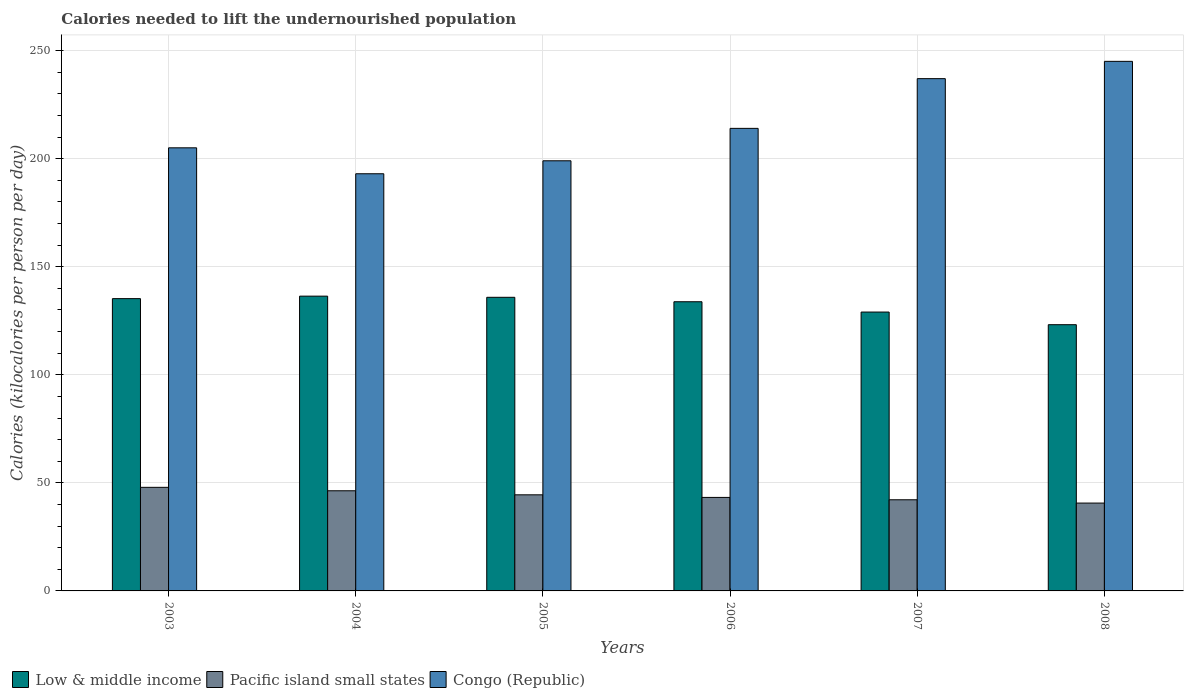How many different coloured bars are there?
Keep it short and to the point. 3. How many groups of bars are there?
Offer a terse response. 6. How many bars are there on the 1st tick from the left?
Offer a terse response. 3. What is the label of the 6th group of bars from the left?
Ensure brevity in your answer.  2008. In how many cases, is the number of bars for a given year not equal to the number of legend labels?
Keep it short and to the point. 0. What is the total calories needed to lift the undernourished population in Pacific island small states in 2004?
Keep it short and to the point. 46.33. Across all years, what is the maximum total calories needed to lift the undernourished population in Pacific island small states?
Your response must be concise. 47.92. Across all years, what is the minimum total calories needed to lift the undernourished population in Pacific island small states?
Your response must be concise. 40.64. In which year was the total calories needed to lift the undernourished population in Congo (Republic) maximum?
Provide a short and direct response. 2008. What is the total total calories needed to lift the undernourished population in Congo (Republic) in the graph?
Ensure brevity in your answer.  1293. What is the difference between the total calories needed to lift the undernourished population in Low & middle income in 2005 and that in 2007?
Your answer should be very brief. 6.83. What is the difference between the total calories needed to lift the undernourished population in Congo (Republic) in 2007 and the total calories needed to lift the undernourished population in Pacific island small states in 2008?
Offer a terse response. 196.36. What is the average total calories needed to lift the undernourished population in Congo (Republic) per year?
Your answer should be very brief. 215.5. In the year 2005, what is the difference between the total calories needed to lift the undernourished population in Pacific island small states and total calories needed to lift the undernourished population in Low & middle income?
Ensure brevity in your answer.  -91.38. What is the ratio of the total calories needed to lift the undernourished population in Low & middle income in 2003 to that in 2006?
Your response must be concise. 1.01. What is the difference between the highest and the second highest total calories needed to lift the undernourished population in Pacific island small states?
Offer a very short reply. 1.59. What is the difference between the highest and the lowest total calories needed to lift the undernourished population in Low & middle income?
Give a very brief answer. 13.21. In how many years, is the total calories needed to lift the undernourished population in Low & middle income greater than the average total calories needed to lift the undernourished population in Low & middle income taken over all years?
Ensure brevity in your answer.  4. Is the sum of the total calories needed to lift the undernourished population in Low & middle income in 2003 and 2008 greater than the maximum total calories needed to lift the undernourished population in Pacific island small states across all years?
Your answer should be compact. Yes. What does the 2nd bar from the left in 2008 represents?
Your answer should be very brief. Pacific island small states. What does the 2nd bar from the right in 2003 represents?
Your response must be concise. Pacific island small states. Is it the case that in every year, the sum of the total calories needed to lift the undernourished population in Low & middle income and total calories needed to lift the undernourished population in Pacific island small states is greater than the total calories needed to lift the undernourished population in Congo (Republic)?
Keep it short and to the point. No. How many years are there in the graph?
Give a very brief answer. 6. What is the difference between two consecutive major ticks on the Y-axis?
Your answer should be compact. 50. Does the graph contain grids?
Offer a terse response. Yes. Where does the legend appear in the graph?
Offer a very short reply. Bottom left. How many legend labels are there?
Provide a short and direct response. 3. How are the legend labels stacked?
Make the answer very short. Horizontal. What is the title of the graph?
Your answer should be compact. Calories needed to lift the undernourished population. What is the label or title of the X-axis?
Your answer should be very brief. Years. What is the label or title of the Y-axis?
Give a very brief answer. Calories (kilocalories per person per day). What is the Calories (kilocalories per person per day) in Low & middle income in 2003?
Offer a very short reply. 135.22. What is the Calories (kilocalories per person per day) in Pacific island small states in 2003?
Give a very brief answer. 47.92. What is the Calories (kilocalories per person per day) in Congo (Republic) in 2003?
Ensure brevity in your answer.  205. What is the Calories (kilocalories per person per day) of Low & middle income in 2004?
Provide a short and direct response. 136.37. What is the Calories (kilocalories per person per day) of Pacific island small states in 2004?
Give a very brief answer. 46.33. What is the Calories (kilocalories per person per day) of Congo (Republic) in 2004?
Provide a short and direct response. 193. What is the Calories (kilocalories per person per day) of Low & middle income in 2005?
Make the answer very short. 135.84. What is the Calories (kilocalories per person per day) in Pacific island small states in 2005?
Make the answer very short. 44.46. What is the Calories (kilocalories per person per day) of Congo (Republic) in 2005?
Your answer should be compact. 199. What is the Calories (kilocalories per person per day) of Low & middle income in 2006?
Keep it short and to the point. 133.78. What is the Calories (kilocalories per person per day) in Pacific island small states in 2006?
Your response must be concise. 43.26. What is the Calories (kilocalories per person per day) in Congo (Republic) in 2006?
Your response must be concise. 214. What is the Calories (kilocalories per person per day) of Low & middle income in 2007?
Ensure brevity in your answer.  129.01. What is the Calories (kilocalories per person per day) in Pacific island small states in 2007?
Offer a terse response. 42.17. What is the Calories (kilocalories per person per day) of Congo (Republic) in 2007?
Ensure brevity in your answer.  237. What is the Calories (kilocalories per person per day) in Low & middle income in 2008?
Make the answer very short. 123.16. What is the Calories (kilocalories per person per day) in Pacific island small states in 2008?
Provide a succinct answer. 40.64. What is the Calories (kilocalories per person per day) in Congo (Republic) in 2008?
Your response must be concise. 245. Across all years, what is the maximum Calories (kilocalories per person per day) of Low & middle income?
Your answer should be very brief. 136.37. Across all years, what is the maximum Calories (kilocalories per person per day) of Pacific island small states?
Your answer should be compact. 47.92. Across all years, what is the maximum Calories (kilocalories per person per day) of Congo (Republic)?
Offer a very short reply. 245. Across all years, what is the minimum Calories (kilocalories per person per day) of Low & middle income?
Your response must be concise. 123.16. Across all years, what is the minimum Calories (kilocalories per person per day) of Pacific island small states?
Ensure brevity in your answer.  40.64. Across all years, what is the minimum Calories (kilocalories per person per day) in Congo (Republic)?
Ensure brevity in your answer.  193. What is the total Calories (kilocalories per person per day) of Low & middle income in the graph?
Make the answer very short. 793.4. What is the total Calories (kilocalories per person per day) of Pacific island small states in the graph?
Give a very brief answer. 264.79. What is the total Calories (kilocalories per person per day) of Congo (Republic) in the graph?
Offer a terse response. 1293. What is the difference between the Calories (kilocalories per person per day) in Low & middle income in 2003 and that in 2004?
Offer a terse response. -1.15. What is the difference between the Calories (kilocalories per person per day) in Pacific island small states in 2003 and that in 2004?
Your answer should be compact. 1.59. What is the difference between the Calories (kilocalories per person per day) in Low & middle income in 2003 and that in 2005?
Your answer should be compact. -0.62. What is the difference between the Calories (kilocalories per person per day) in Pacific island small states in 2003 and that in 2005?
Ensure brevity in your answer.  3.47. What is the difference between the Calories (kilocalories per person per day) in Congo (Republic) in 2003 and that in 2005?
Make the answer very short. 6. What is the difference between the Calories (kilocalories per person per day) in Low & middle income in 2003 and that in 2006?
Your response must be concise. 1.44. What is the difference between the Calories (kilocalories per person per day) of Pacific island small states in 2003 and that in 2006?
Give a very brief answer. 4.66. What is the difference between the Calories (kilocalories per person per day) in Congo (Republic) in 2003 and that in 2006?
Provide a short and direct response. -9. What is the difference between the Calories (kilocalories per person per day) in Low & middle income in 2003 and that in 2007?
Keep it short and to the point. 6.21. What is the difference between the Calories (kilocalories per person per day) of Pacific island small states in 2003 and that in 2007?
Offer a terse response. 5.75. What is the difference between the Calories (kilocalories per person per day) in Congo (Republic) in 2003 and that in 2007?
Your answer should be very brief. -32. What is the difference between the Calories (kilocalories per person per day) of Low & middle income in 2003 and that in 2008?
Provide a succinct answer. 12.06. What is the difference between the Calories (kilocalories per person per day) in Pacific island small states in 2003 and that in 2008?
Keep it short and to the point. 7.28. What is the difference between the Calories (kilocalories per person per day) in Low & middle income in 2004 and that in 2005?
Your response must be concise. 0.54. What is the difference between the Calories (kilocalories per person per day) of Pacific island small states in 2004 and that in 2005?
Keep it short and to the point. 1.87. What is the difference between the Calories (kilocalories per person per day) in Low & middle income in 2004 and that in 2006?
Keep it short and to the point. 2.59. What is the difference between the Calories (kilocalories per person per day) in Pacific island small states in 2004 and that in 2006?
Make the answer very short. 3.07. What is the difference between the Calories (kilocalories per person per day) in Low & middle income in 2004 and that in 2007?
Offer a very short reply. 7.36. What is the difference between the Calories (kilocalories per person per day) of Pacific island small states in 2004 and that in 2007?
Provide a succinct answer. 4.16. What is the difference between the Calories (kilocalories per person per day) in Congo (Republic) in 2004 and that in 2007?
Offer a terse response. -44. What is the difference between the Calories (kilocalories per person per day) in Low & middle income in 2004 and that in 2008?
Ensure brevity in your answer.  13.21. What is the difference between the Calories (kilocalories per person per day) of Pacific island small states in 2004 and that in 2008?
Provide a short and direct response. 5.69. What is the difference between the Calories (kilocalories per person per day) of Congo (Republic) in 2004 and that in 2008?
Offer a very short reply. -52. What is the difference between the Calories (kilocalories per person per day) of Low & middle income in 2005 and that in 2006?
Offer a terse response. 2.06. What is the difference between the Calories (kilocalories per person per day) in Pacific island small states in 2005 and that in 2006?
Your answer should be very brief. 1.19. What is the difference between the Calories (kilocalories per person per day) in Low & middle income in 2005 and that in 2007?
Make the answer very short. 6.83. What is the difference between the Calories (kilocalories per person per day) of Pacific island small states in 2005 and that in 2007?
Your answer should be compact. 2.29. What is the difference between the Calories (kilocalories per person per day) in Congo (Republic) in 2005 and that in 2007?
Provide a short and direct response. -38. What is the difference between the Calories (kilocalories per person per day) of Low & middle income in 2005 and that in 2008?
Offer a very short reply. 12.68. What is the difference between the Calories (kilocalories per person per day) in Pacific island small states in 2005 and that in 2008?
Offer a very short reply. 3.81. What is the difference between the Calories (kilocalories per person per day) of Congo (Republic) in 2005 and that in 2008?
Offer a very short reply. -46. What is the difference between the Calories (kilocalories per person per day) in Low & middle income in 2006 and that in 2007?
Give a very brief answer. 4.77. What is the difference between the Calories (kilocalories per person per day) in Pacific island small states in 2006 and that in 2007?
Keep it short and to the point. 1.09. What is the difference between the Calories (kilocalories per person per day) of Low & middle income in 2006 and that in 2008?
Ensure brevity in your answer.  10.62. What is the difference between the Calories (kilocalories per person per day) of Pacific island small states in 2006 and that in 2008?
Your answer should be very brief. 2.62. What is the difference between the Calories (kilocalories per person per day) of Congo (Republic) in 2006 and that in 2008?
Your answer should be compact. -31. What is the difference between the Calories (kilocalories per person per day) in Low & middle income in 2007 and that in 2008?
Provide a short and direct response. 5.85. What is the difference between the Calories (kilocalories per person per day) in Pacific island small states in 2007 and that in 2008?
Your response must be concise. 1.53. What is the difference between the Calories (kilocalories per person per day) in Congo (Republic) in 2007 and that in 2008?
Provide a short and direct response. -8. What is the difference between the Calories (kilocalories per person per day) of Low & middle income in 2003 and the Calories (kilocalories per person per day) of Pacific island small states in 2004?
Keep it short and to the point. 88.89. What is the difference between the Calories (kilocalories per person per day) of Low & middle income in 2003 and the Calories (kilocalories per person per day) of Congo (Republic) in 2004?
Keep it short and to the point. -57.78. What is the difference between the Calories (kilocalories per person per day) in Pacific island small states in 2003 and the Calories (kilocalories per person per day) in Congo (Republic) in 2004?
Your answer should be very brief. -145.08. What is the difference between the Calories (kilocalories per person per day) of Low & middle income in 2003 and the Calories (kilocalories per person per day) of Pacific island small states in 2005?
Your answer should be compact. 90.77. What is the difference between the Calories (kilocalories per person per day) of Low & middle income in 2003 and the Calories (kilocalories per person per day) of Congo (Republic) in 2005?
Offer a very short reply. -63.78. What is the difference between the Calories (kilocalories per person per day) of Pacific island small states in 2003 and the Calories (kilocalories per person per day) of Congo (Republic) in 2005?
Your answer should be compact. -151.08. What is the difference between the Calories (kilocalories per person per day) in Low & middle income in 2003 and the Calories (kilocalories per person per day) in Pacific island small states in 2006?
Give a very brief answer. 91.96. What is the difference between the Calories (kilocalories per person per day) in Low & middle income in 2003 and the Calories (kilocalories per person per day) in Congo (Republic) in 2006?
Your answer should be very brief. -78.78. What is the difference between the Calories (kilocalories per person per day) of Pacific island small states in 2003 and the Calories (kilocalories per person per day) of Congo (Republic) in 2006?
Keep it short and to the point. -166.08. What is the difference between the Calories (kilocalories per person per day) in Low & middle income in 2003 and the Calories (kilocalories per person per day) in Pacific island small states in 2007?
Offer a very short reply. 93.05. What is the difference between the Calories (kilocalories per person per day) of Low & middle income in 2003 and the Calories (kilocalories per person per day) of Congo (Republic) in 2007?
Your answer should be compact. -101.78. What is the difference between the Calories (kilocalories per person per day) of Pacific island small states in 2003 and the Calories (kilocalories per person per day) of Congo (Republic) in 2007?
Keep it short and to the point. -189.08. What is the difference between the Calories (kilocalories per person per day) of Low & middle income in 2003 and the Calories (kilocalories per person per day) of Pacific island small states in 2008?
Offer a terse response. 94.58. What is the difference between the Calories (kilocalories per person per day) of Low & middle income in 2003 and the Calories (kilocalories per person per day) of Congo (Republic) in 2008?
Your answer should be very brief. -109.78. What is the difference between the Calories (kilocalories per person per day) in Pacific island small states in 2003 and the Calories (kilocalories per person per day) in Congo (Republic) in 2008?
Offer a very short reply. -197.08. What is the difference between the Calories (kilocalories per person per day) of Low & middle income in 2004 and the Calories (kilocalories per person per day) of Pacific island small states in 2005?
Your answer should be very brief. 91.92. What is the difference between the Calories (kilocalories per person per day) of Low & middle income in 2004 and the Calories (kilocalories per person per day) of Congo (Republic) in 2005?
Offer a terse response. -62.62. What is the difference between the Calories (kilocalories per person per day) of Pacific island small states in 2004 and the Calories (kilocalories per person per day) of Congo (Republic) in 2005?
Offer a terse response. -152.67. What is the difference between the Calories (kilocalories per person per day) of Low & middle income in 2004 and the Calories (kilocalories per person per day) of Pacific island small states in 2006?
Offer a very short reply. 93.11. What is the difference between the Calories (kilocalories per person per day) of Low & middle income in 2004 and the Calories (kilocalories per person per day) of Congo (Republic) in 2006?
Keep it short and to the point. -77.62. What is the difference between the Calories (kilocalories per person per day) of Pacific island small states in 2004 and the Calories (kilocalories per person per day) of Congo (Republic) in 2006?
Provide a succinct answer. -167.67. What is the difference between the Calories (kilocalories per person per day) in Low & middle income in 2004 and the Calories (kilocalories per person per day) in Pacific island small states in 2007?
Offer a terse response. 94.2. What is the difference between the Calories (kilocalories per person per day) of Low & middle income in 2004 and the Calories (kilocalories per person per day) of Congo (Republic) in 2007?
Provide a succinct answer. -100.62. What is the difference between the Calories (kilocalories per person per day) of Pacific island small states in 2004 and the Calories (kilocalories per person per day) of Congo (Republic) in 2007?
Give a very brief answer. -190.67. What is the difference between the Calories (kilocalories per person per day) in Low & middle income in 2004 and the Calories (kilocalories per person per day) in Pacific island small states in 2008?
Offer a very short reply. 95.73. What is the difference between the Calories (kilocalories per person per day) of Low & middle income in 2004 and the Calories (kilocalories per person per day) of Congo (Republic) in 2008?
Provide a short and direct response. -108.62. What is the difference between the Calories (kilocalories per person per day) of Pacific island small states in 2004 and the Calories (kilocalories per person per day) of Congo (Republic) in 2008?
Provide a succinct answer. -198.67. What is the difference between the Calories (kilocalories per person per day) in Low & middle income in 2005 and the Calories (kilocalories per person per day) in Pacific island small states in 2006?
Your answer should be very brief. 92.58. What is the difference between the Calories (kilocalories per person per day) of Low & middle income in 2005 and the Calories (kilocalories per person per day) of Congo (Republic) in 2006?
Provide a succinct answer. -78.16. What is the difference between the Calories (kilocalories per person per day) of Pacific island small states in 2005 and the Calories (kilocalories per person per day) of Congo (Republic) in 2006?
Provide a short and direct response. -169.54. What is the difference between the Calories (kilocalories per person per day) in Low & middle income in 2005 and the Calories (kilocalories per person per day) in Pacific island small states in 2007?
Provide a succinct answer. 93.67. What is the difference between the Calories (kilocalories per person per day) in Low & middle income in 2005 and the Calories (kilocalories per person per day) in Congo (Republic) in 2007?
Offer a terse response. -101.16. What is the difference between the Calories (kilocalories per person per day) in Pacific island small states in 2005 and the Calories (kilocalories per person per day) in Congo (Republic) in 2007?
Your answer should be very brief. -192.54. What is the difference between the Calories (kilocalories per person per day) in Low & middle income in 2005 and the Calories (kilocalories per person per day) in Pacific island small states in 2008?
Ensure brevity in your answer.  95.2. What is the difference between the Calories (kilocalories per person per day) in Low & middle income in 2005 and the Calories (kilocalories per person per day) in Congo (Republic) in 2008?
Keep it short and to the point. -109.16. What is the difference between the Calories (kilocalories per person per day) of Pacific island small states in 2005 and the Calories (kilocalories per person per day) of Congo (Republic) in 2008?
Provide a short and direct response. -200.54. What is the difference between the Calories (kilocalories per person per day) in Low & middle income in 2006 and the Calories (kilocalories per person per day) in Pacific island small states in 2007?
Give a very brief answer. 91.61. What is the difference between the Calories (kilocalories per person per day) of Low & middle income in 2006 and the Calories (kilocalories per person per day) of Congo (Republic) in 2007?
Provide a short and direct response. -103.22. What is the difference between the Calories (kilocalories per person per day) in Pacific island small states in 2006 and the Calories (kilocalories per person per day) in Congo (Republic) in 2007?
Provide a short and direct response. -193.74. What is the difference between the Calories (kilocalories per person per day) in Low & middle income in 2006 and the Calories (kilocalories per person per day) in Pacific island small states in 2008?
Provide a succinct answer. 93.14. What is the difference between the Calories (kilocalories per person per day) of Low & middle income in 2006 and the Calories (kilocalories per person per day) of Congo (Republic) in 2008?
Give a very brief answer. -111.22. What is the difference between the Calories (kilocalories per person per day) in Pacific island small states in 2006 and the Calories (kilocalories per person per day) in Congo (Republic) in 2008?
Give a very brief answer. -201.74. What is the difference between the Calories (kilocalories per person per day) in Low & middle income in 2007 and the Calories (kilocalories per person per day) in Pacific island small states in 2008?
Offer a terse response. 88.37. What is the difference between the Calories (kilocalories per person per day) in Low & middle income in 2007 and the Calories (kilocalories per person per day) in Congo (Republic) in 2008?
Your answer should be compact. -115.99. What is the difference between the Calories (kilocalories per person per day) of Pacific island small states in 2007 and the Calories (kilocalories per person per day) of Congo (Republic) in 2008?
Your answer should be compact. -202.83. What is the average Calories (kilocalories per person per day) of Low & middle income per year?
Offer a very short reply. 132.23. What is the average Calories (kilocalories per person per day) in Pacific island small states per year?
Offer a terse response. 44.13. What is the average Calories (kilocalories per person per day) in Congo (Republic) per year?
Your answer should be compact. 215.5. In the year 2003, what is the difference between the Calories (kilocalories per person per day) of Low & middle income and Calories (kilocalories per person per day) of Pacific island small states?
Give a very brief answer. 87.3. In the year 2003, what is the difference between the Calories (kilocalories per person per day) in Low & middle income and Calories (kilocalories per person per day) in Congo (Republic)?
Provide a short and direct response. -69.78. In the year 2003, what is the difference between the Calories (kilocalories per person per day) in Pacific island small states and Calories (kilocalories per person per day) in Congo (Republic)?
Offer a very short reply. -157.08. In the year 2004, what is the difference between the Calories (kilocalories per person per day) of Low & middle income and Calories (kilocalories per person per day) of Pacific island small states?
Your response must be concise. 90.05. In the year 2004, what is the difference between the Calories (kilocalories per person per day) in Low & middle income and Calories (kilocalories per person per day) in Congo (Republic)?
Provide a short and direct response. -56.62. In the year 2004, what is the difference between the Calories (kilocalories per person per day) in Pacific island small states and Calories (kilocalories per person per day) in Congo (Republic)?
Your answer should be very brief. -146.67. In the year 2005, what is the difference between the Calories (kilocalories per person per day) in Low & middle income and Calories (kilocalories per person per day) in Pacific island small states?
Provide a short and direct response. 91.38. In the year 2005, what is the difference between the Calories (kilocalories per person per day) of Low & middle income and Calories (kilocalories per person per day) of Congo (Republic)?
Give a very brief answer. -63.16. In the year 2005, what is the difference between the Calories (kilocalories per person per day) in Pacific island small states and Calories (kilocalories per person per day) in Congo (Republic)?
Give a very brief answer. -154.54. In the year 2006, what is the difference between the Calories (kilocalories per person per day) in Low & middle income and Calories (kilocalories per person per day) in Pacific island small states?
Provide a short and direct response. 90.52. In the year 2006, what is the difference between the Calories (kilocalories per person per day) of Low & middle income and Calories (kilocalories per person per day) of Congo (Republic)?
Keep it short and to the point. -80.22. In the year 2006, what is the difference between the Calories (kilocalories per person per day) in Pacific island small states and Calories (kilocalories per person per day) in Congo (Republic)?
Offer a very short reply. -170.74. In the year 2007, what is the difference between the Calories (kilocalories per person per day) of Low & middle income and Calories (kilocalories per person per day) of Pacific island small states?
Provide a short and direct response. 86.84. In the year 2007, what is the difference between the Calories (kilocalories per person per day) in Low & middle income and Calories (kilocalories per person per day) in Congo (Republic)?
Make the answer very short. -107.99. In the year 2007, what is the difference between the Calories (kilocalories per person per day) in Pacific island small states and Calories (kilocalories per person per day) in Congo (Republic)?
Provide a short and direct response. -194.83. In the year 2008, what is the difference between the Calories (kilocalories per person per day) of Low & middle income and Calories (kilocalories per person per day) of Pacific island small states?
Provide a succinct answer. 82.52. In the year 2008, what is the difference between the Calories (kilocalories per person per day) in Low & middle income and Calories (kilocalories per person per day) in Congo (Republic)?
Make the answer very short. -121.84. In the year 2008, what is the difference between the Calories (kilocalories per person per day) in Pacific island small states and Calories (kilocalories per person per day) in Congo (Republic)?
Your response must be concise. -204.36. What is the ratio of the Calories (kilocalories per person per day) in Low & middle income in 2003 to that in 2004?
Your answer should be compact. 0.99. What is the ratio of the Calories (kilocalories per person per day) in Pacific island small states in 2003 to that in 2004?
Provide a short and direct response. 1.03. What is the ratio of the Calories (kilocalories per person per day) of Congo (Republic) in 2003 to that in 2004?
Offer a terse response. 1.06. What is the ratio of the Calories (kilocalories per person per day) of Low & middle income in 2003 to that in 2005?
Ensure brevity in your answer.  1. What is the ratio of the Calories (kilocalories per person per day) of Pacific island small states in 2003 to that in 2005?
Keep it short and to the point. 1.08. What is the ratio of the Calories (kilocalories per person per day) of Congo (Republic) in 2003 to that in 2005?
Provide a succinct answer. 1.03. What is the ratio of the Calories (kilocalories per person per day) of Low & middle income in 2003 to that in 2006?
Make the answer very short. 1.01. What is the ratio of the Calories (kilocalories per person per day) in Pacific island small states in 2003 to that in 2006?
Provide a succinct answer. 1.11. What is the ratio of the Calories (kilocalories per person per day) of Congo (Republic) in 2003 to that in 2006?
Offer a very short reply. 0.96. What is the ratio of the Calories (kilocalories per person per day) of Low & middle income in 2003 to that in 2007?
Give a very brief answer. 1.05. What is the ratio of the Calories (kilocalories per person per day) in Pacific island small states in 2003 to that in 2007?
Ensure brevity in your answer.  1.14. What is the ratio of the Calories (kilocalories per person per day) of Congo (Republic) in 2003 to that in 2007?
Make the answer very short. 0.86. What is the ratio of the Calories (kilocalories per person per day) of Low & middle income in 2003 to that in 2008?
Your answer should be very brief. 1.1. What is the ratio of the Calories (kilocalories per person per day) of Pacific island small states in 2003 to that in 2008?
Provide a short and direct response. 1.18. What is the ratio of the Calories (kilocalories per person per day) in Congo (Republic) in 2003 to that in 2008?
Offer a terse response. 0.84. What is the ratio of the Calories (kilocalories per person per day) in Pacific island small states in 2004 to that in 2005?
Provide a succinct answer. 1.04. What is the ratio of the Calories (kilocalories per person per day) of Congo (Republic) in 2004 to that in 2005?
Keep it short and to the point. 0.97. What is the ratio of the Calories (kilocalories per person per day) in Low & middle income in 2004 to that in 2006?
Offer a very short reply. 1.02. What is the ratio of the Calories (kilocalories per person per day) in Pacific island small states in 2004 to that in 2006?
Make the answer very short. 1.07. What is the ratio of the Calories (kilocalories per person per day) in Congo (Republic) in 2004 to that in 2006?
Your answer should be compact. 0.9. What is the ratio of the Calories (kilocalories per person per day) in Low & middle income in 2004 to that in 2007?
Provide a succinct answer. 1.06. What is the ratio of the Calories (kilocalories per person per day) in Pacific island small states in 2004 to that in 2007?
Give a very brief answer. 1.1. What is the ratio of the Calories (kilocalories per person per day) of Congo (Republic) in 2004 to that in 2007?
Keep it short and to the point. 0.81. What is the ratio of the Calories (kilocalories per person per day) of Low & middle income in 2004 to that in 2008?
Give a very brief answer. 1.11. What is the ratio of the Calories (kilocalories per person per day) in Pacific island small states in 2004 to that in 2008?
Make the answer very short. 1.14. What is the ratio of the Calories (kilocalories per person per day) in Congo (Republic) in 2004 to that in 2008?
Make the answer very short. 0.79. What is the ratio of the Calories (kilocalories per person per day) in Low & middle income in 2005 to that in 2006?
Offer a terse response. 1.02. What is the ratio of the Calories (kilocalories per person per day) of Pacific island small states in 2005 to that in 2006?
Offer a very short reply. 1.03. What is the ratio of the Calories (kilocalories per person per day) of Congo (Republic) in 2005 to that in 2006?
Give a very brief answer. 0.93. What is the ratio of the Calories (kilocalories per person per day) of Low & middle income in 2005 to that in 2007?
Provide a short and direct response. 1.05. What is the ratio of the Calories (kilocalories per person per day) of Pacific island small states in 2005 to that in 2007?
Provide a succinct answer. 1.05. What is the ratio of the Calories (kilocalories per person per day) in Congo (Republic) in 2005 to that in 2007?
Provide a short and direct response. 0.84. What is the ratio of the Calories (kilocalories per person per day) in Low & middle income in 2005 to that in 2008?
Offer a very short reply. 1.1. What is the ratio of the Calories (kilocalories per person per day) in Pacific island small states in 2005 to that in 2008?
Your response must be concise. 1.09. What is the ratio of the Calories (kilocalories per person per day) of Congo (Republic) in 2005 to that in 2008?
Make the answer very short. 0.81. What is the ratio of the Calories (kilocalories per person per day) of Pacific island small states in 2006 to that in 2007?
Give a very brief answer. 1.03. What is the ratio of the Calories (kilocalories per person per day) in Congo (Republic) in 2006 to that in 2007?
Give a very brief answer. 0.9. What is the ratio of the Calories (kilocalories per person per day) of Low & middle income in 2006 to that in 2008?
Offer a terse response. 1.09. What is the ratio of the Calories (kilocalories per person per day) in Pacific island small states in 2006 to that in 2008?
Give a very brief answer. 1.06. What is the ratio of the Calories (kilocalories per person per day) in Congo (Republic) in 2006 to that in 2008?
Offer a very short reply. 0.87. What is the ratio of the Calories (kilocalories per person per day) of Low & middle income in 2007 to that in 2008?
Make the answer very short. 1.05. What is the ratio of the Calories (kilocalories per person per day) in Pacific island small states in 2007 to that in 2008?
Keep it short and to the point. 1.04. What is the ratio of the Calories (kilocalories per person per day) of Congo (Republic) in 2007 to that in 2008?
Provide a succinct answer. 0.97. What is the difference between the highest and the second highest Calories (kilocalories per person per day) of Low & middle income?
Offer a very short reply. 0.54. What is the difference between the highest and the second highest Calories (kilocalories per person per day) of Pacific island small states?
Make the answer very short. 1.59. What is the difference between the highest and the lowest Calories (kilocalories per person per day) in Low & middle income?
Your response must be concise. 13.21. What is the difference between the highest and the lowest Calories (kilocalories per person per day) of Pacific island small states?
Make the answer very short. 7.28. 